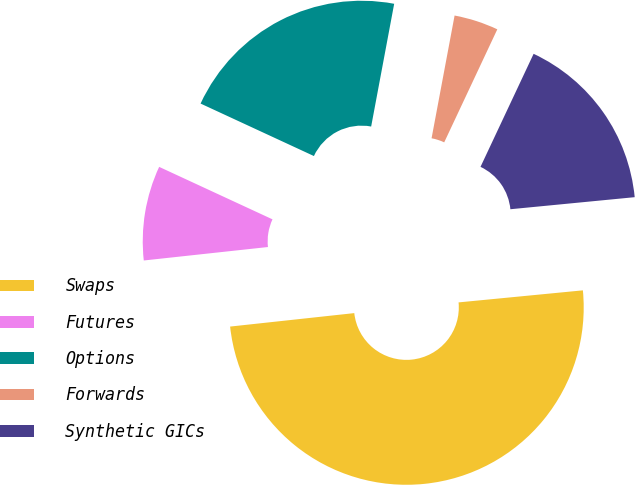Convert chart to OTSL. <chart><loc_0><loc_0><loc_500><loc_500><pie_chart><fcel>Swaps<fcel>Futures<fcel>Options<fcel>Forwards<fcel>Synthetic GICs<nl><fcel>49.82%<fcel>8.62%<fcel>21.05%<fcel>4.04%<fcel>16.47%<nl></chart> 